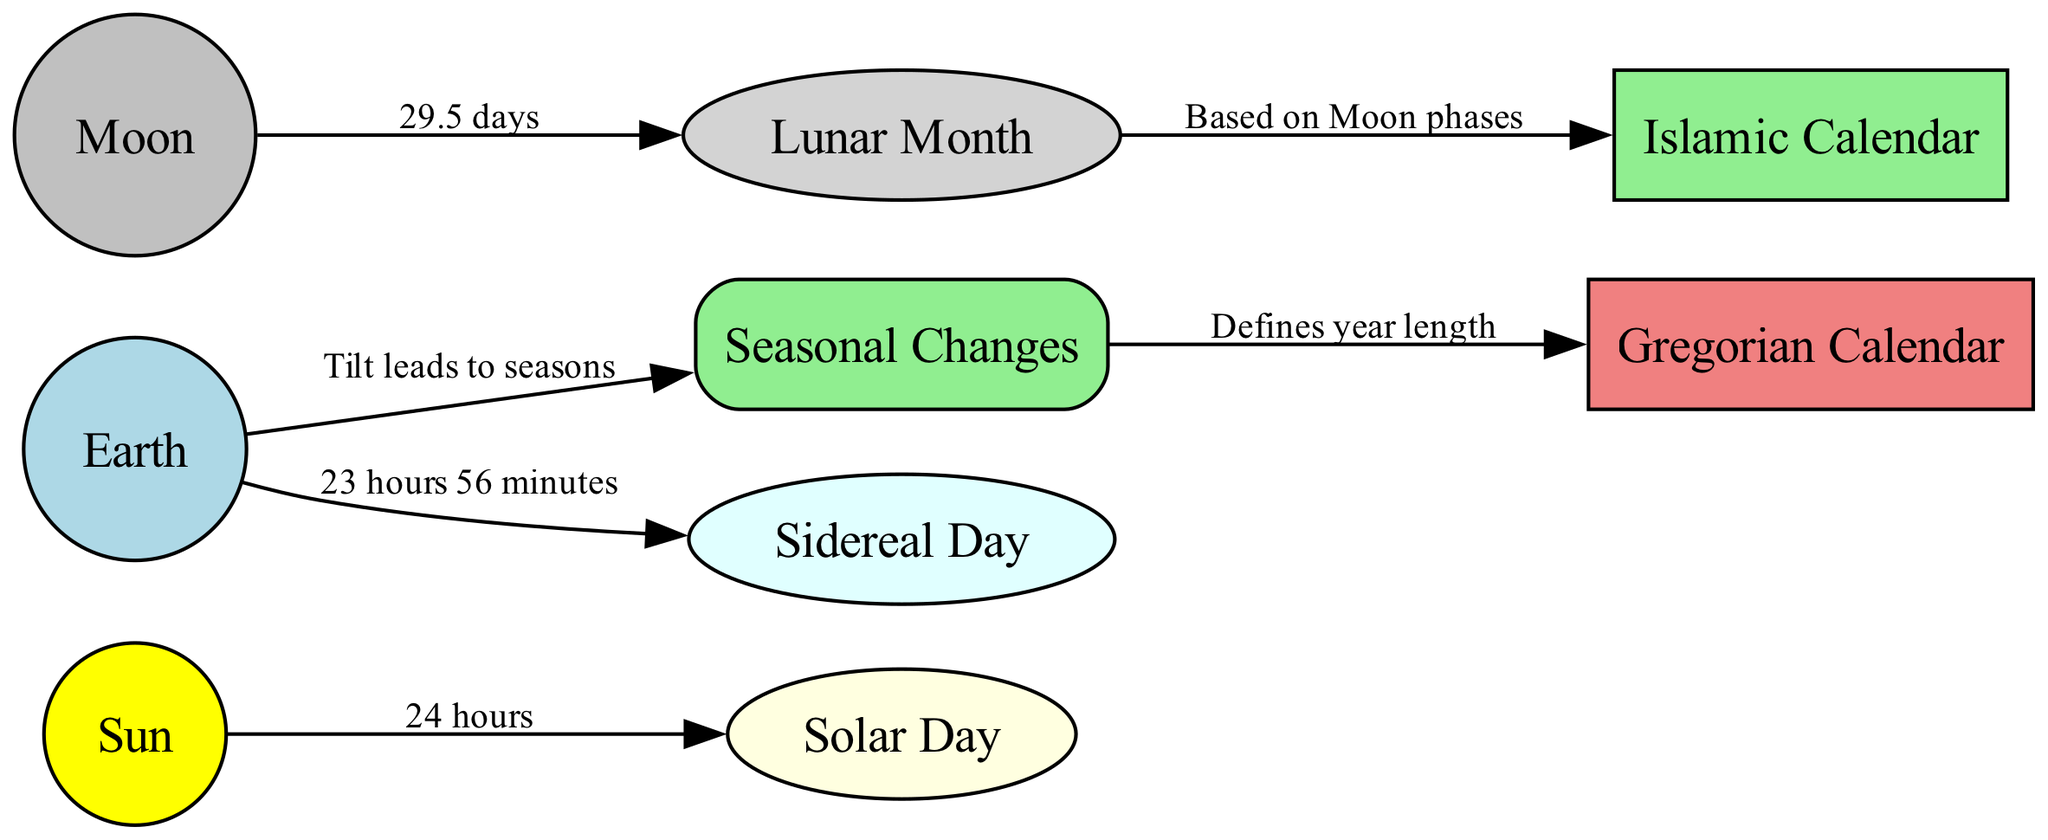What is the length of a solar day? The diagram shows a direct edge from the "Sun" node to the "Solar Day" node, indicating that a solar day is equivalent to 24 hours.
Answer: 24 hours What defines the length of a year in the Gregorian calendar? The diagram indicates that "Seasonal Changes" directly impacts the "Gregorian Calendar", highlighting that the year length is defined by seasonal changes.
Answer: Seasonal Changes What is the duration of a lunar month? The relationship between the "Moon" and "Lunar Month" is shown in the diagram with a label stating that a lunar month lasts 29.5 days.
Answer: 29.5 days Which calendar is based on lunar phases? In the diagram, it shows an edge from "Lunar Month" to "Islamic Calendar" stating that the Islamic calendar is based on moon phases.
Answer: Islamic Calendar How long is a sidereal day? The edge from "Earth" to "Sidereal Day" reveals that a sidereal day lasts 23 hours and 56 minutes.
Answer: 23 hours 56 minutes What astronomical body is responsible for the seasonal changes? According to the diagram, the "Earth" node branches out to "Seasonal Changes", indicating that the Earth is responsible for these changes.
Answer: Earth How many main nodes are present in the diagram? By counting the nodes listed in the provided data, there are a total of nine distinct nodes in the diagram.
Answer: 9 Which calendar system is directly connected to the solar day? The diagram connects the "Sun" to the "Solar Day", which indicates that the solar day is influenced by the sun.
Answer: Solar Day What event leads to the definition of seasonal changes? The diagram shows that the tilt of the Earth affects "Seasonal Changes", indicating that this tilt leads to the seasonal variations.
Answer: Tilt leads to seasons 